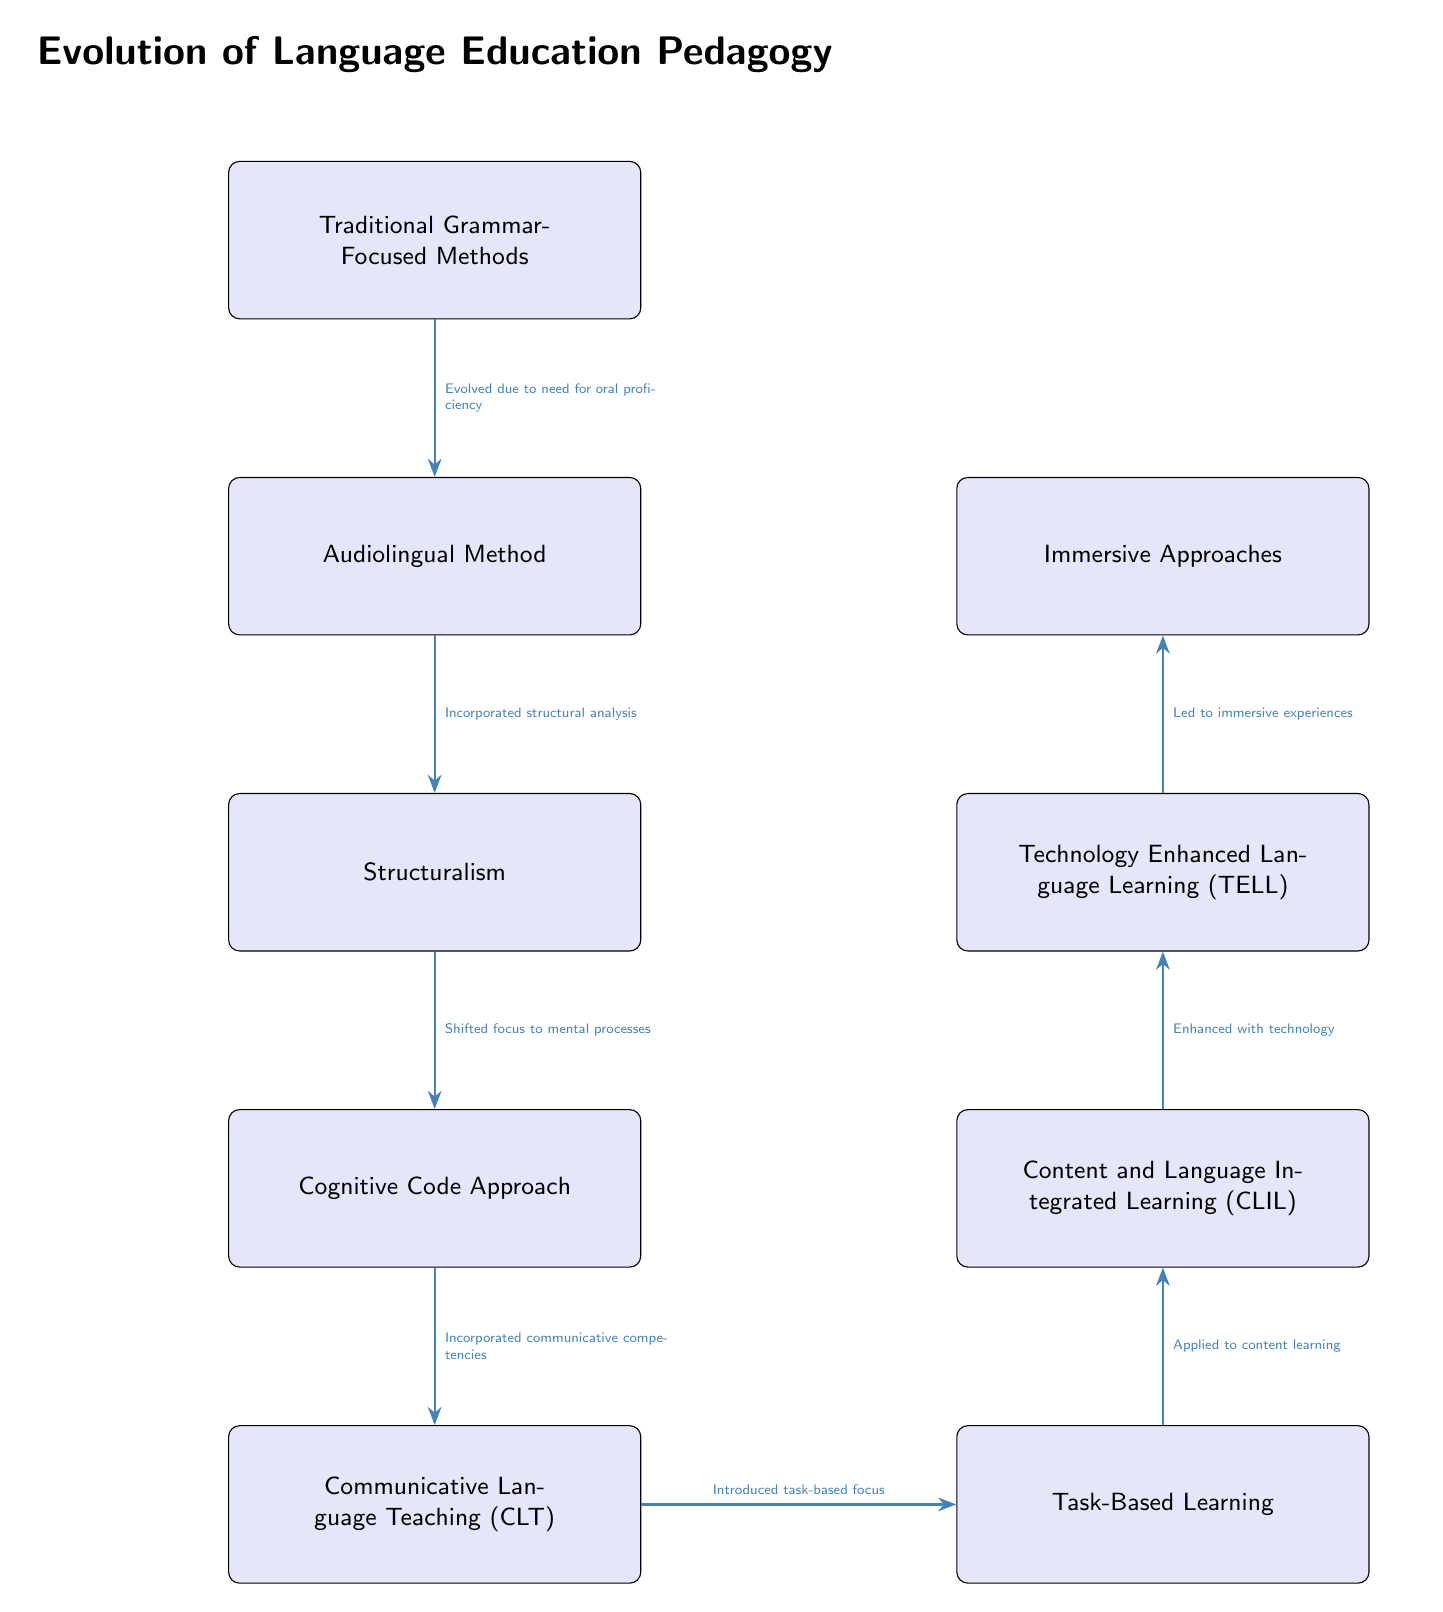What is the first method in the evolution of language education pedagogy? The first method listed in the diagram is "Traditional Grammar-Focused Methods," located at the top of the flowchart.
Answer: Traditional Grammar-Focused Methods How many total methods are represented in this flowchart? There are a total of nine methods presented in the diagram, starting from "Traditional Grammar-Focused Methods" down to "Immersive Approaches."
Answer: 9 What method follows the Audiolingual Method? The method that follows the Audiolingual Method, according to the flowchart, is "Structuralism."
Answer: Structuralism Which approach describes the incorporation of communicative competencies? The approach that describes the incorporation of communicative competencies is "Communicative Language Teaching (CLT)," which is identified in the path leading from the "Cognitive Code Approach."
Answer: Communicative Language Teaching (CLT) What is the main focus introduced after "Communicative Language Teaching (CLT)"? The main focus introduced after "Communicative Language Teaching (CLT)" is "Task-Based Learning," which is directly connected to CLT in the flowchart.
Answer: Task-Based Learning What is the final approach in the progression of language education pedagogy? The final approach in the flowchart, representing the last stage in the evolution of language education pedagogy, is "Immersive Approaches."
Answer: Immersive Approaches What relationship is indicated between "Task-Based Learning" and "Content and Language Integrated Learning (CLIL)"? The relationship indicated is that "Task-Based Learning" is applied to "Content and Language Integrated Learning (CLIL)," as shown by an arrow connecting the two in the flowchart.
Answer: Applied to content learning Which method highlights the enhancement with technology? The method that highlights the enhancement with technology is "Technology Enhanced Language Learning (TELL)," appearing right before "Immersive Approaches" in the diagram.
Answer: Technology Enhanced Language Learning (TELL) What is the significance of the arrows in the diagram? The arrows signify the progression and relationships between different methods in language education pedagogy, indicating how each method evolves or relates to the next.
Answer: Progression and relationships 